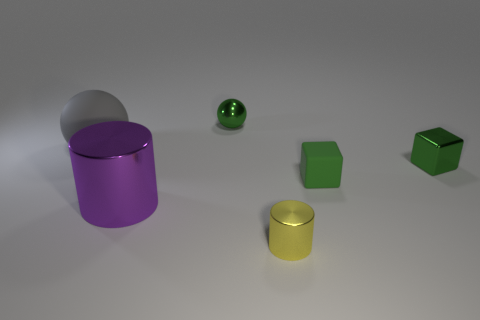Subtract all gray spheres. How many spheres are left? 1 Add 2 blue metallic cubes. How many objects exist? 8 Subtract all cubes. How many objects are left? 4 Subtract all gray cylinders. Subtract all purple cubes. How many cylinders are left? 2 Subtract all blue balls. How many purple cubes are left? 0 Subtract all tiny purple spheres. Subtract all tiny green metal things. How many objects are left? 4 Add 1 big purple cylinders. How many big purple cylinders are left? 2 Add 3 large spheres. How many large spheres exist? 4 Subtract 0 blue blocks. How many objects are left? 6 Subtract 2 cubes. How many cubes are left? 0 